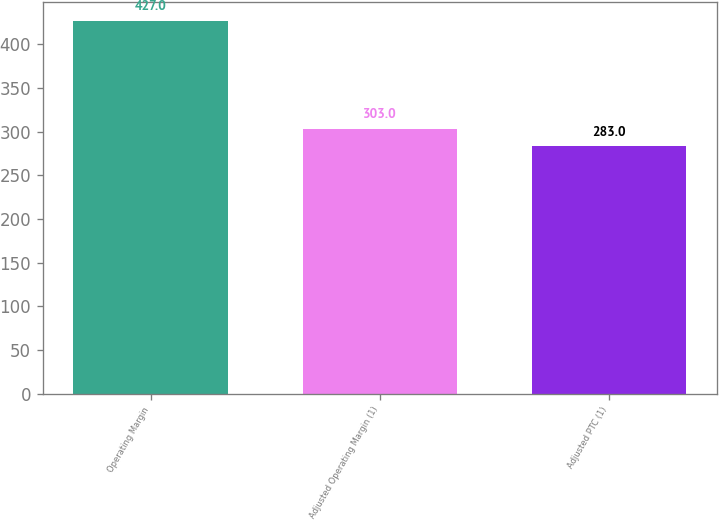Convert chart. <chart><loc_0><loc_0><loc_500><loc_500><bar_chart><fcel>Operating Margin<fcel>Adjusted Operating Margin (1)<fcel>Adjusted PTC (1)<nl><fcel>427<fcel>303<fcel>283<nl></chart> 